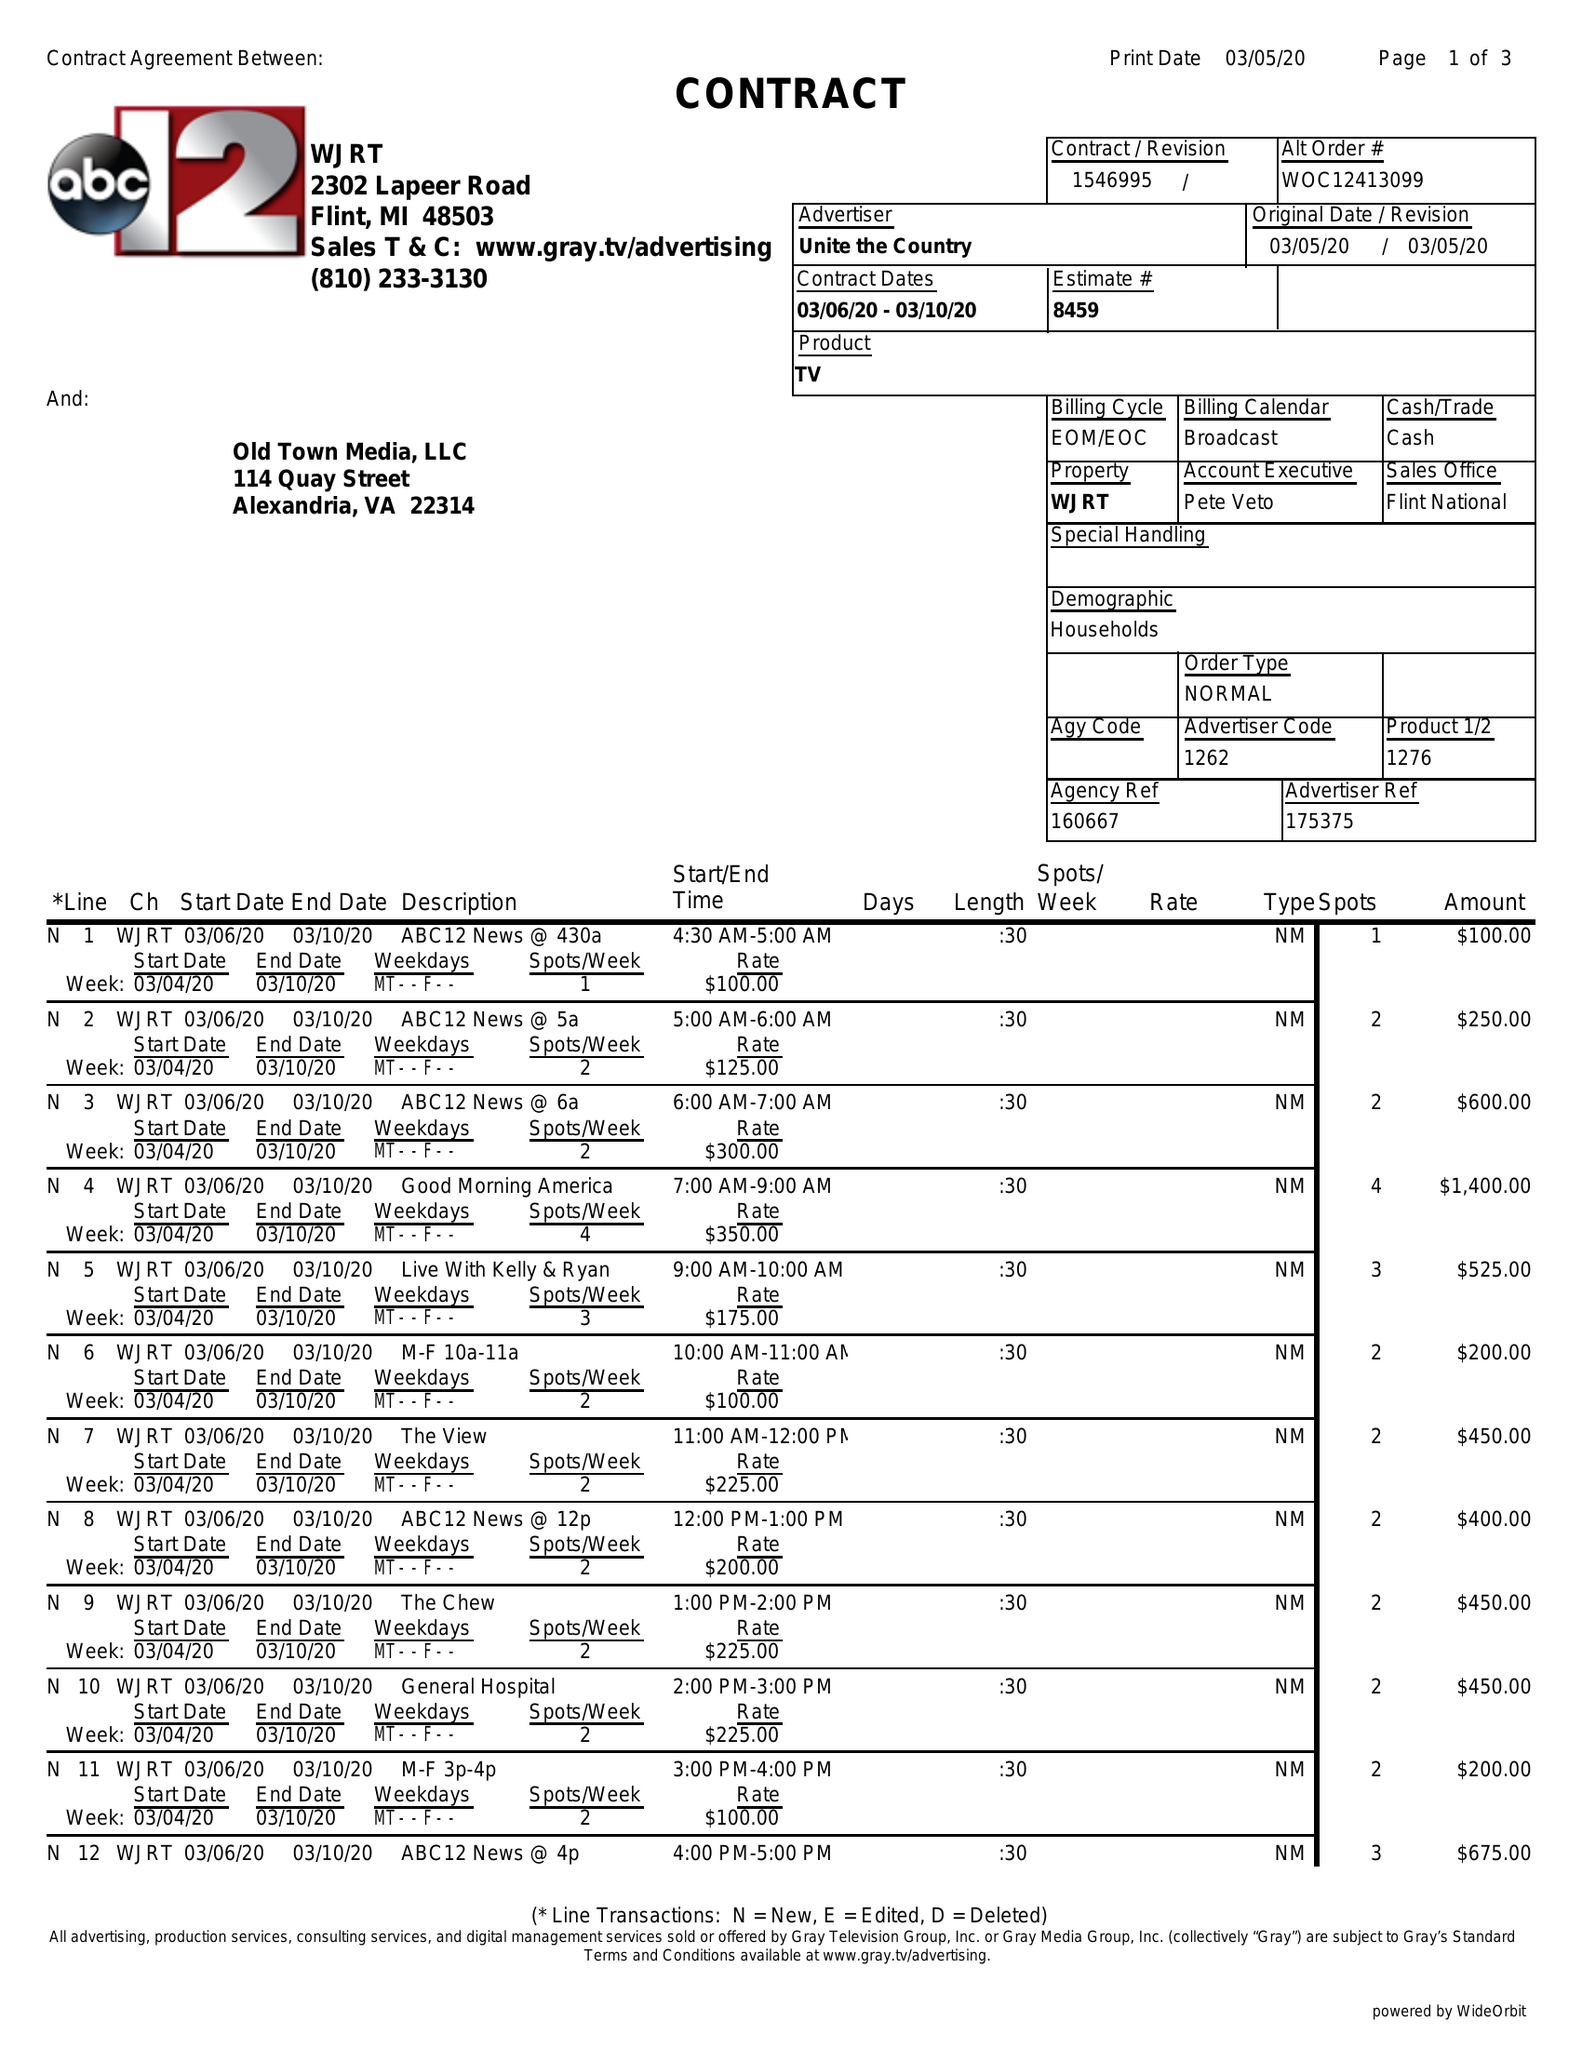What is the value for the contract_num?
Answer the question using a single word or phrase. 1546995 